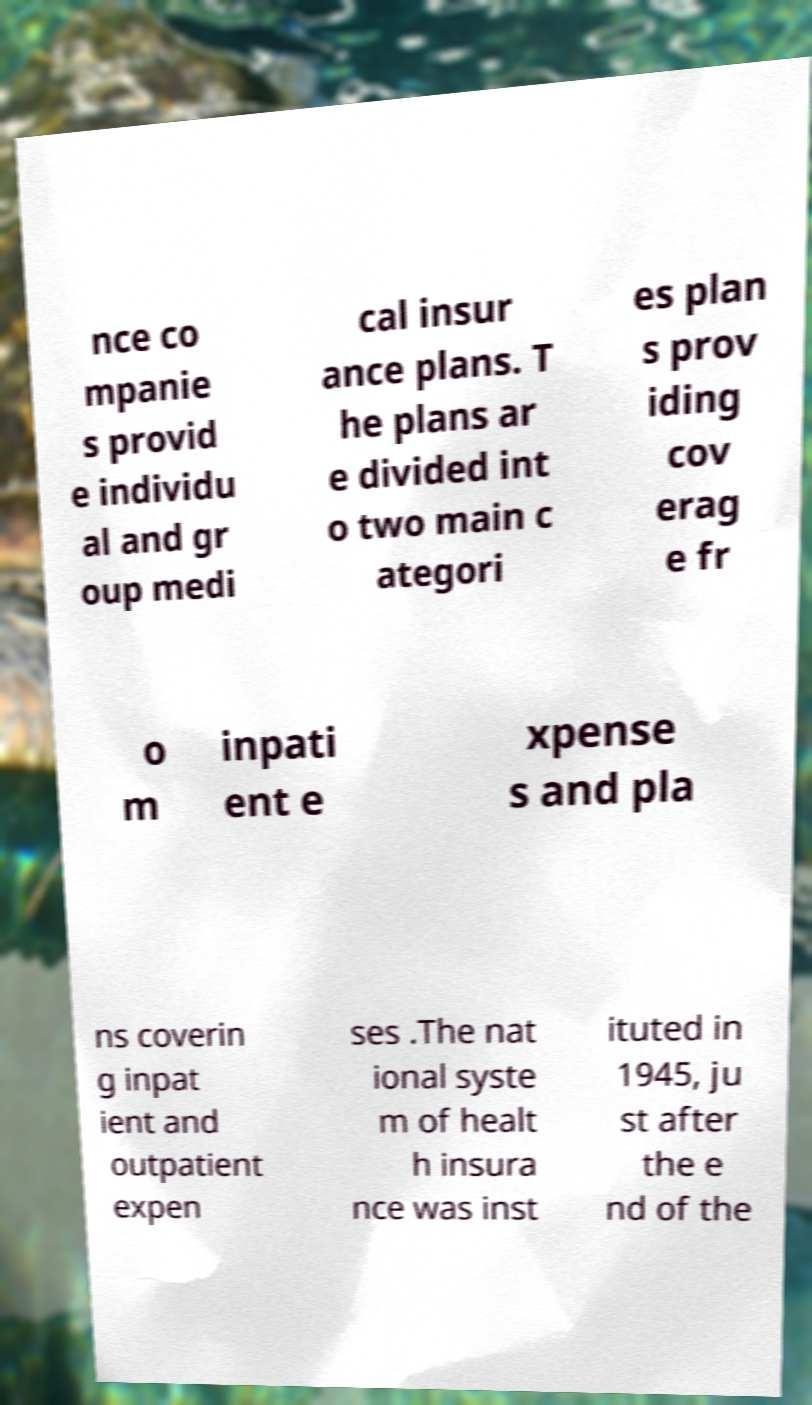Please read and relay the text visible in this image. What does it say? nce co mpanie s provid e individu al and gr oup medi cal insur ance plans. T he plans ar e divided int o two main c ategori es plan s prov iding cov erag e fr o m inpati ent e xpense s and pla ns coverin g inpat ient and outpatient expen ses .The nat ional syste m of healt h insura nce was inst ituted in 1945, ju st after the e nd of the 